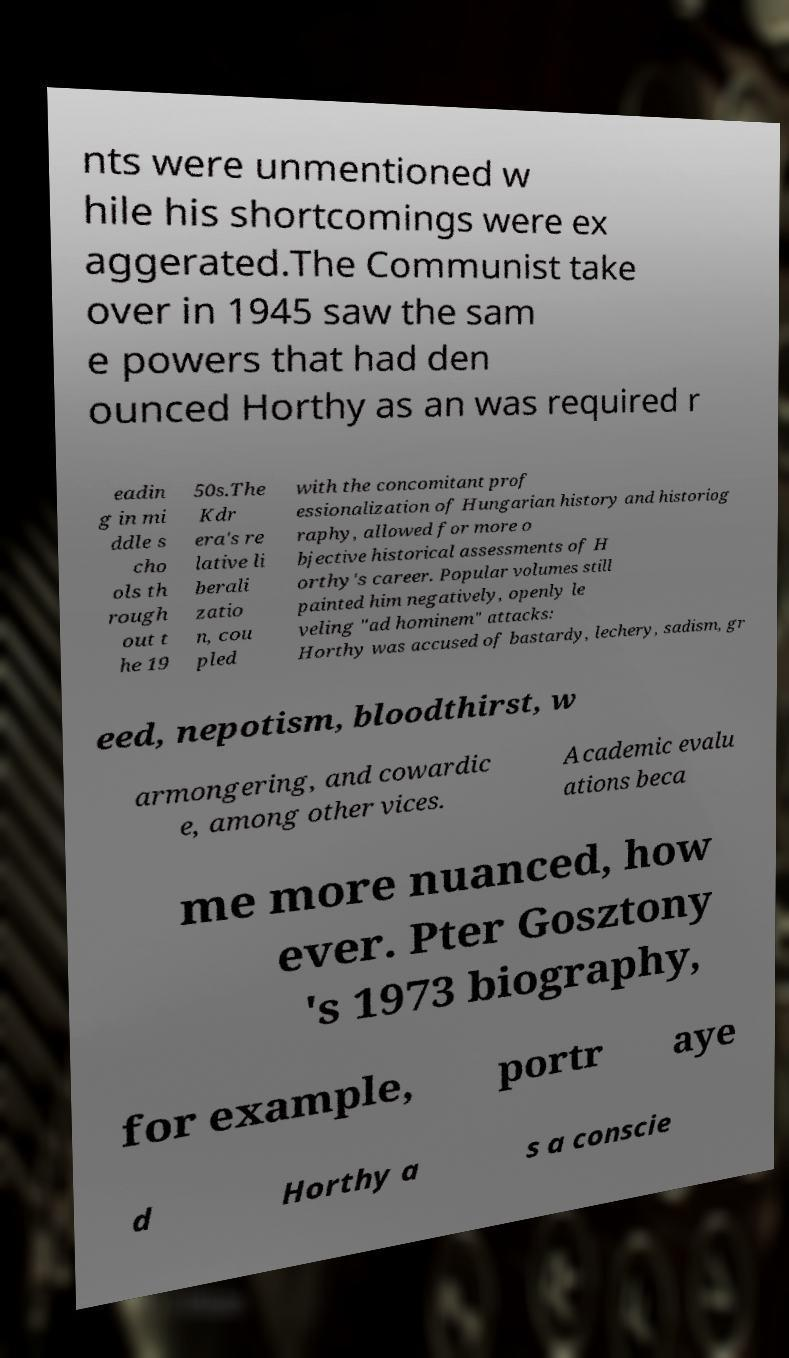Can you accurately transcribe the text from the provided image for me? nts were unmentioned w hile his shortcomings were ex aggerated.The Communist take over in 1945 saw the sam e powers that had den ounced Horthy as an was required r eadin g in mi ddle s cho ols th rough out t he 19 50s.The Kdr era's re lative li berali zatio n, cou pled with the concomitant prof essionalization of Hungarian history and historiog raphy, allowed for more o bjective historical assessments of H orthy's career. Popular volumes still painted him negatively, openly le veling "ad hominem" attacks: Horthy was accused of bastardy, lechery, sadism, gr eed, nepotism, bloodthirst, w armongering, and cowardic e, among other vices. Academic evalu ations beca me more nuanced, how ever. Pter Gosztony 's 1973 biography, for example, portr aye d Horthy a s a conscie 